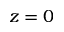<formula> <loc_0><loc_0><loc_500><loc_500>z = 0</formula> 